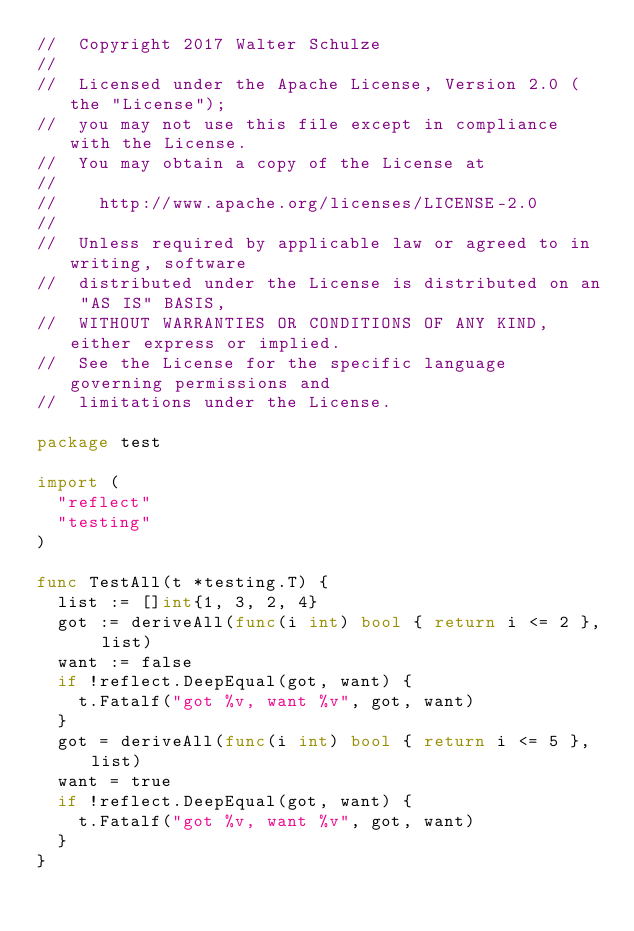Convert code to text. <code><loc_0><loc_0><loc_500><loc_500><_Go_>//  Copyright 2017 Walter Schulze
//
//  Licensed under the Apache License, Version 2.0 (the "License");
//  you may not use this file except in compliance with the License.
//  You may obtain a copy of the License at
//
//    http://www.apache.org/licenses/LICENSE-2.0
//
//  Unless required by applicable law or agreed to in writing, software
//  distributed under the License is distributed on an "AS IS" BASIS,
//  WITHOUT WARRANTIES OR CONDITIONS OF ANY KIND, either express or implied.
//  See the License for the specific language governing permissions and
//  limitations under the License.

package test

import (
	"reflect"
	"testing"
)

func TestAll(t *testing.T) {
	list := []int{1, 3, 2, 4}
	got := deriveAll(func(i int) bool { return i <= 2 }, list)
	want := false
	if !reflect.DeepEqual(got, want) {
		t.Fatalf("got %v, want %v", got, want)
	}
	got = deriveAll(func(i int) bool { return i <= 5 }, list)
	want = true
	if !reflect.DeepEqual(got, want) {
		t.Fatalf("got %v, want %v", got, want)
	}
}
</code> 